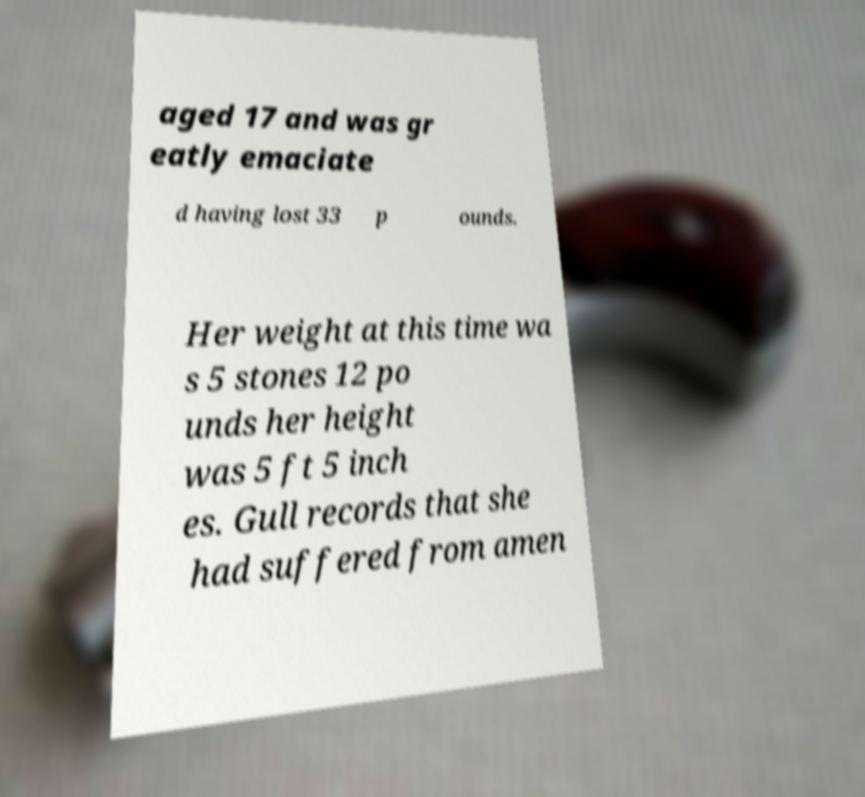Can you read and provide the text displayed in the image?This photo seems to have some interesting text. Can you extract and type it out for me? aged 17 and was gr eatly emaciate d having lost 33 p ounds. Her weight at this time wa s 5 stones 12 po unds her height was 5 ft 5 inch es. Gull records that she had suffered from amen 